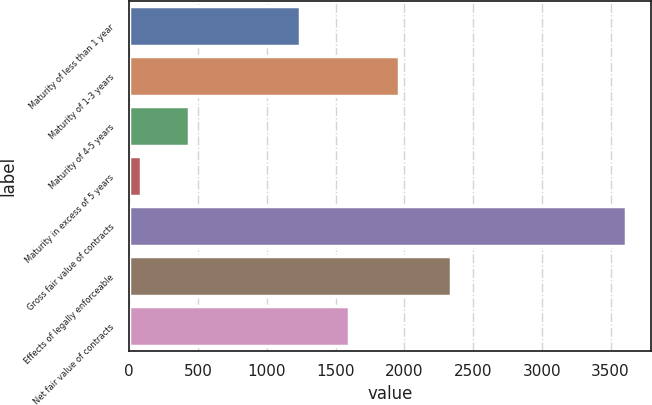Convert chart. <chart><loc_0><loc_0><loc_500><loc_500><bar_chart><fcel>Maturity of less than 1 year<fcel>Maturity of 1-3 years<fcel>Maturity of 4-5 years<fcel>Maturity in excess of 5 years<fcel>Gross fair value of contracts<fcel>Effects of legally enforceable<fcel>Net fair value of contracts<nl><fcel>1244<fcel>1963<fcel>435.8<fcel>83<fcel>3611<fcel>2339<fcel>1596.8<nl></chart> 